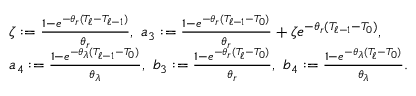Convert formula to latex. <formula><loc_0><loc_0><loc_500><loc_500>\begin{array} { r l } & { \zeta \colon = \frac { 1 - e ^ { - \theta _ { r } ( T _ { \ell } - T _ { \ell - 1 } ) } } { \theta _ { r } } , \ a _ { 3 } \colon = \frac { 1 - e ^ { - \theta _ { r } ( T _ { \ell - 1 } - T _ { 0 } ) } } { \theta _ { r } } + \zeta e ^ { - \theta _ { r } ( T _ { \ell - 1 } - T _ { 0 } ) } , } \\ & { a _ { 4 } \colon = \frac { 1 - e ^ { - \theta _ { \lambda } ( T _ { \ell - 1 } - T _ { 0 } ) } } { \theta _ { \lambda } } , \ b _ { 3 } \colon = \frac { 1 - e ^ { - \theta _ { r } ( T _ { \ell } - T _ { 0 } ) } } { \theta _ { r } } , \ b _ { 4 } \colon = \frac { 1 - e ^ { - \theta _ { \lambda } ( T _ { \ell } - T _ { 0 } ) } } { \theta _ { \lambda } } . } \end{array}</formula> 